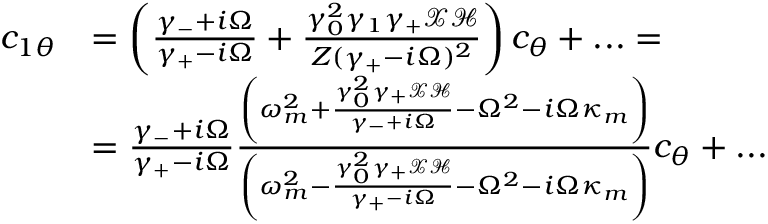<formula> <loc_0><loc_0><loc_500><loc_500>\begin{array} { r l } { c _ { 1 \theta } } & { = \left ( \frac { \gamma _ { - } + i \Omega } { \gamma _ { + } - i \Omega } + \frac { \gamma _ { 0 } ^ { 2 } \gamma _ { 1 } \gamma _ { + } \mathcal { X } \mathcal { H } } { Z ( \gamma _ { + } - i \Omega ) ^ { 2 } } \right ) c _ { \theta } + \dots = } \\ & { = \frac { \gamma _ { - } + i \Omega } { \gamma _ { + } - i \Omega } \frac { \left ( \omega _ { m } ^ { 2 } + \frac { \gamma _ { 0 } ^ { 2 } \gamma _ { + } \mathcal { X } \mathcal { H } } { \gamma _ { - } + i \Omega } - \Omega ^ { 2 } - i \Omega \kappa _ { m } \right ) } { \left ( \omega _ { m } ^ { 2 } - \frac { \gamma _ { 0 } ^ { 2 } \gamma _ { + } \mathcal { X } \mathcal { H } } { \gamma _ { + } - i \Omega } - \Omega ^ { 2 } - i \Omega \kappa _ { m } \right ) } c _ { \theta } + \dots } \end{array}</formula> 